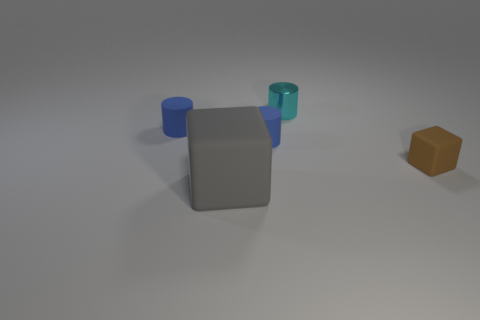Subtract all blue cylinders. How many were subtracted if there are1blue cylinders left? 1 Subtract all blue matte cylinders. How many cylinders are left? 1 Add 1 big blue shiny cylinders. How many objects exist? 6 Subtract all cylinders. How many objects are left? 2 Add 2 blue cylinders. How many blue cylinders exist? 4 Subtract 0 purple blocks. How many objects are left? 5 Subtract all purple metallic objects. Subtract all tiny blue matte cylinders. How many objects are left? 3 Add 2 large gray objects. How many large gray objects are left? 3 